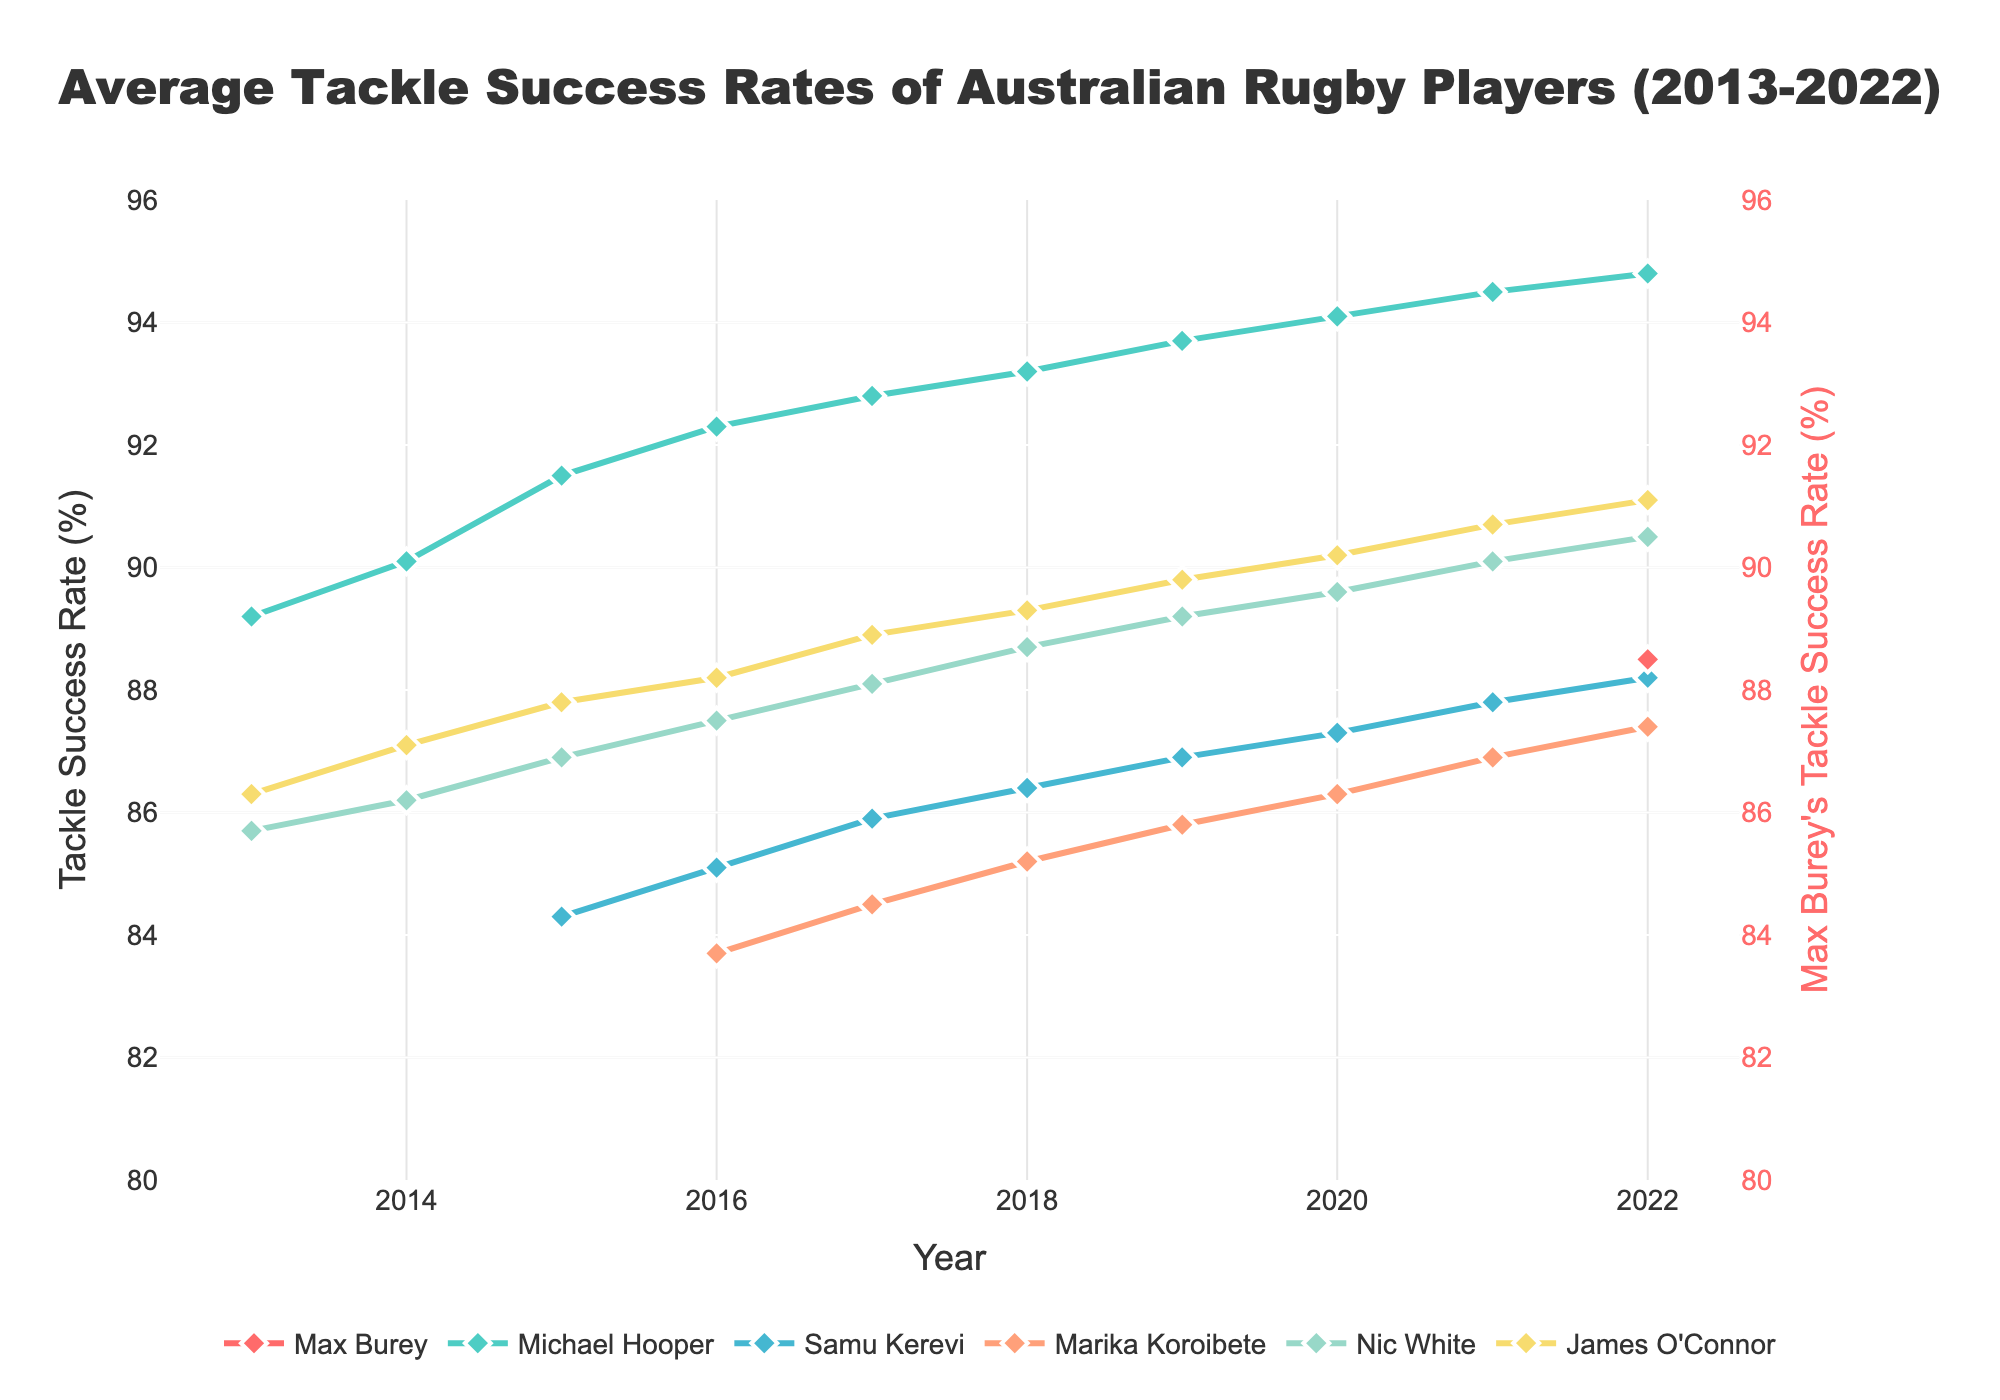What trend can be observed in Michael Hooper's tackle success rate over the years? To determine the trend of Michael Hooper's tackle success rate, look at his line on the chart. Since it starts in 2013 and steadily increases every year until 2022, we can conclude that his tackle success rate has been improving steadily.
Answer: Increasing Which player had the highest tackle success rate in 2022? To answer this, look at the points representing 2022 for each player. The figure shows that Michael Hooper had the highest tackle success rate in 2022.
Answer: Michael Hooper How does Max Burey's 2022 tackle success rate compare to Nic White's? To compare, locate the points for Max Burey and Nic White in 2022. Max Burey's tackle success rate was slightly lower than Nic White's in 2022 (88.5% vs. 90.5%).
Answer: Lower In which year did Marika Koroibete's tackle success rate first surpass 85%? Locate Marika Koroibete’s line on the chart and identify the first occurrence where her tackle success rate exceeds 85%. This happened in 2018.
Answer: 2018 What is the average tackle success rate of James O'Connor from 2013 to 2022? To find the average, sum up James O'Connor’s tackle success rates from 2013 to 2022 and divide by the number of years (10). Sum: 86.3 + 87.1 + 87.8 + 88.2 + 88.9 + 89.3 + 89.8 + 90.2 + 90.7 + 91.1 = 889.4, then divide by 10: 889.4/10 = 88.94.
Answer: 88.94 Which player showed the greatest improvement in tackle success rate from 2013 to 2022? Assess the initial and final tackle success rates of each player. Michael Hooper’s tackle success rate increased from 89.2% in 2013 to 94.8% in 2022, the most significant improvement among all players.
Answer: Michael Hooper Compare the tackle success rate trends of Samu Kerevi and Marika Koroibete between 2015 and 2022. Look at the lines for Samu Kerevi and Marika Koroibete from 2015 to 2022. Both trends show an improvement, but Samu Kerevi's success rates increased more gradually compared to Marika Koroibete.
Answer: Both improved, Samu Kerevi more gradually What is the difference in tackle success rates between Max Burey and Michael Hooper in 2022? In 2022, Max Burey's tackle success rate was 88.5% and Michael Hooper's was 94.8%. The difference is calculated as 94.8 - 88.5 = 6.3%.
Answer: 6.3% Identify the year with the highest average tackle success rate among all players. Calculate the average tackle success rate for each year by summing the rates and dividing by the number of players listed that year. The year 2022 has the highest averages due to generally higher rates across all players.
Answer: 2022 